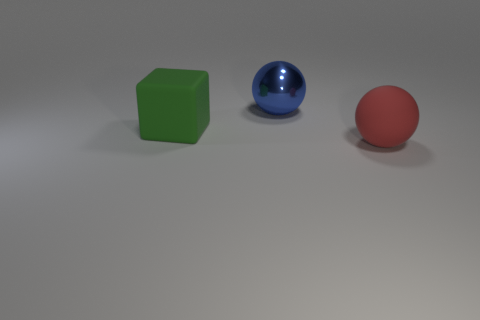Add 3 large objects. How many objects exist? 6 Subtract all blocks. How many objects are left? 2 Subtract all tiny blue cylinders. Subtract all big red balls. How many objects are left? 2 Add 2 large cubes. How many large cubes are left? 3 Add 3 red matte balls. How many red matte balls exist? 4 Subtract 0 yellow cylinders. How many objects are left? 3 